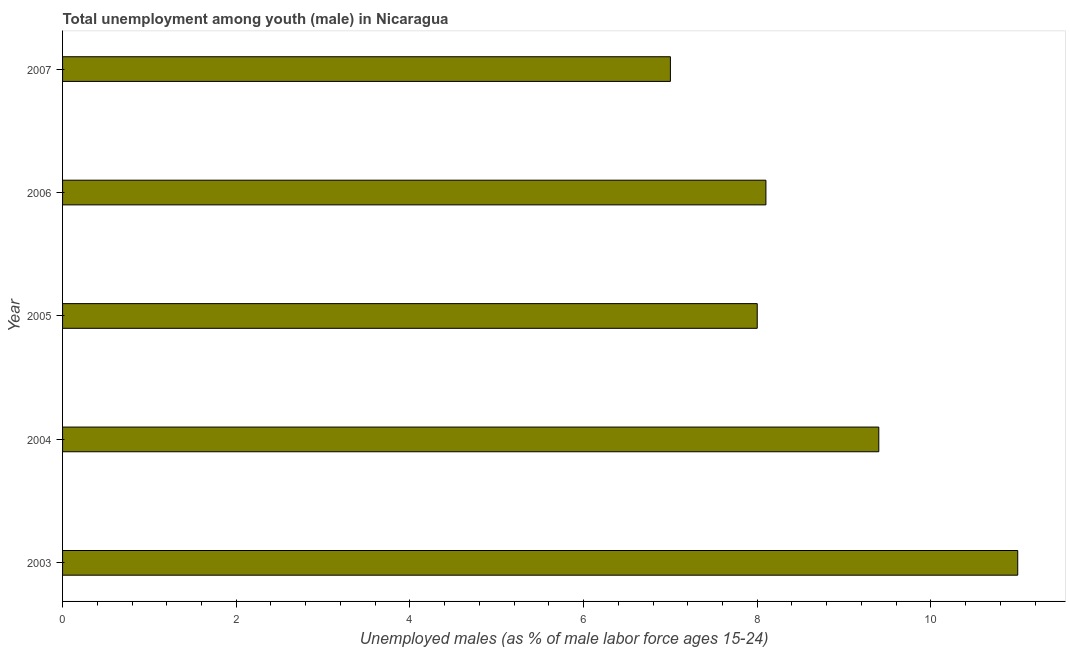Does the graph contain any zero values?
Give a very brief answer. No. What is the title of the graph?
Provide a short and direct response. Total unemployment among youth (male) in Nicaragua. What is the label or title of the X-axis?
Your answer should be very brief. Unemployed males (as % of male labor force ages 15-24). What is the unemployed male youth population in 2006?
Give a very brief answer. 8.1. Across all years, what is the minimum unemployed male youth population?
Offer a very short reply. 7. In which year was the unemployed male youth population maximum?
Your answer should be compact. 2003. What is the sum of the unemployed male youth population?
Make the answer very short. 43.5. What is the difference between the unemployed male youth population in 2006 and 2007?
Make the answer very short. 1.1. What is the average unemployed male youth population per year?
Your answer should be very brief. 8.7. What is the median unemployed male youth population?
Ensure brevity in your answer.  8.1. In how many years, is the unemployed male youth population greater than 3.2 %?
Offer a very short reply. 5. What is the ratio of the unemployed male youth population in 2004 to that in 2006?
Offer a very short reply. 1.16. Is the difference between the unemployed male youth population in 2005 and 2007 greater than the difference between any two years?
Offer a very short reply. No. How many bars are there?
Ensure brevity in your answer.  5. How many years are there in the graph?
Provide a short and direct response. 5. Are the values on the major ticks of X-axis written in scientific E-notation?
Provide a succinct answer. No. What is the Unemployed males (as % of male labor force ages 15-24) of 2003?
Offer a terse response. 11. What is the Unemployed males (as % of male labor force ages 15-24) in 2004?
Your answer should be compact. 9.4. What is the Unemployed males (as % of male labor force ages 15-24) of 2006?
Offer a very short reply. 8.1. What is the Unemployed males (as % of male labor force ages 15-24) in 2007?
Your answer should be very brief. 7. What is the difference between the Unemployed males (as % of male labor force ages 15-24) in 2003 and 2004?
Make the answer very short. 1.6. What is the difference between the Unemployed males (as % of male labor force ages 15-24) in 2003 and 2005?
Your answer should be very brief. 3. What is the difference between the Unemployed males (as % of male labor force ages 15-24) in 2003 and 2006?
Provide a succinct answer. 2.9. What is the difference between the Unemployed males (as % of male labor force ages 15-24) in 2005 and 2006?
Keep it short and to the point. -0.1. What is the difference between the Unemployed males (as % of male labor force ages 15-24) in 2005 and 2007?
Keep it short and to the point. 1. What is the difference between the Unemployed males (as % of male labor force ages 15-24) in 2006 and 2007?
Ensure brevity in your answer.  1.1. What is the ratio of the Unemployed males (as % of male labor force ages 15-24) in 2003 to that in 2004?
Your response must be concise. 1.17. What is the ratio of the Unemployed males (as % of male labor force ages 15-24) in 2003 to that in 2005?
Make the answer very short. 1.38. What is the ratio of the Unemployed males (as % of male labor force ages 15-24) in 2003 to that in 2006?
Offer a very short reply. 1.36. What is the ratio of the Unemployed males (as % of male labor force ages 15-24) in 2003 to that in 2007?
Offer a terse response. 1.57. What is the ratio of the Unemployed males (as % of male labor force ages 15-24) in 2004 to that in 2005?
Ensure brevity in your answer.  1.18. What is the ratio of the Unemployed males (as % of male labor force ages 15-24) in 2004 to that in 2006?
Offer a terse response. 1.16. What is the ratio of the Unemployed males (as % of male labor force ages 15-24) in 2004 to that in 2007?
Make the answer very short. 1.34. What is the ratio of the Unemployed males (as % of male labor force ages 15-24) in 2005 to that in 2007?
Your response must be concise. 1.14. What is the ratio of the Unemployed males (as % of male labor force ages 15-24) in 2006 to that in 2007?
Provide a succinct answer. 1.16. 